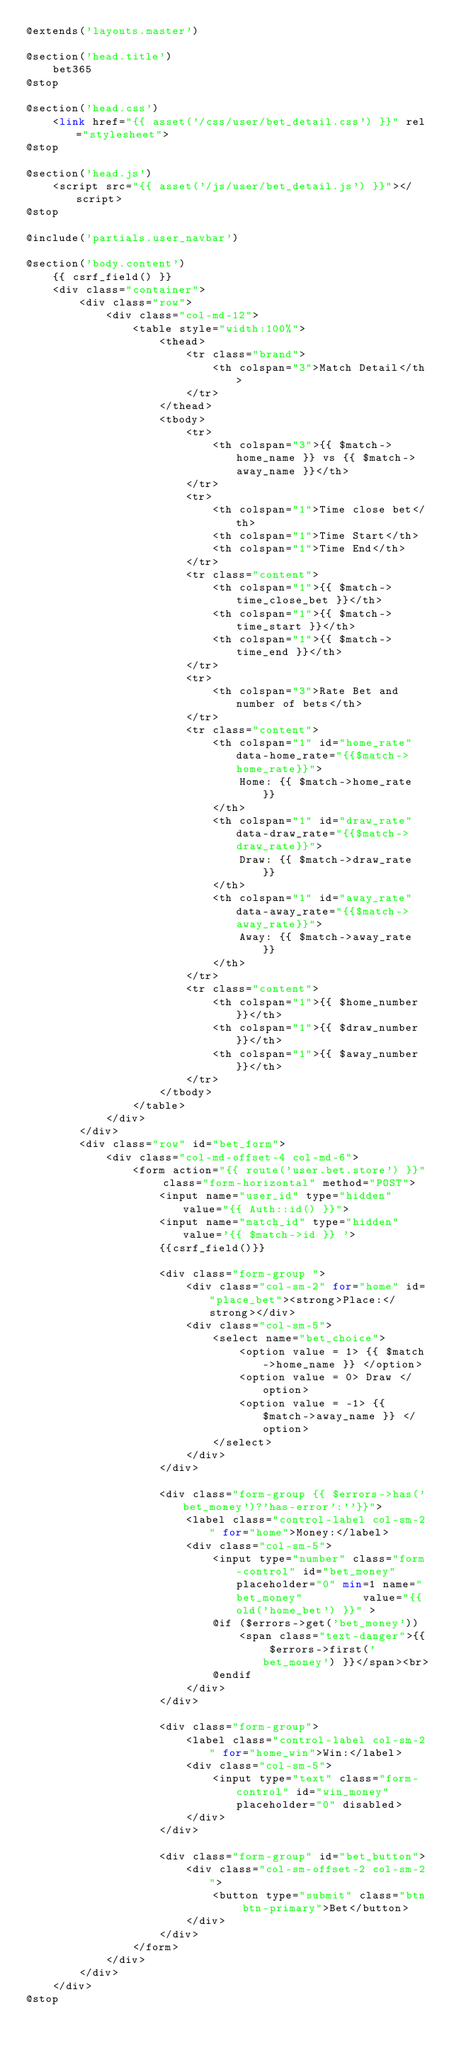<code> <loc_0><loc_0><loc_500><loc_500><_PHP_>@extends('layouts.master')

@section('head.title')
    bet365
@stop

@section('head.css')
    <link href="{{ asset('/css/user/bet_detail.css') }}" rel="stylesheet">
@stop

@section('head.js')
    <script src="{{ asset('/js/user/bet_detail.js') }}"></script> 
@stop

@include('partials.user_navbar')

@section('body.content')
    {{ csrf_field() }}
    <div class="container">
        <div class="row">
            <div class="col-md-12">
                <table style="width:100%">
                    <thead>
                        <tr class="brand">
                            <th colspan="3">Match Detail</th>
                        </tr>
                    </thead>
                    <tbody>
                        <tr>
                            <th colspan="3">{{ $match->home_name }} vs {{ $match->away_name }}</th>
                        </tr>
                        <tr>
                            <th colspan="1">Time close bet</th>
                            <th colspan="1">Time Start</th>
                            <th colspan="1">Time End</th>
                        </tr>
                        <tr class="content">
                            <th colspan="1">{{ $match->time_close_bet }}</th>
                            <th colspan="1">{{ $match->time_start }}</th>
                            <th colspan="1">{{ $match->time_end }}</th>
                        </tr>
                        <tr>
                            <th colspan="3">Rate Bet and number of bets</th>
                        </tr>
                        <tr class="content">
                            <th colspan="1" id="home_rate" data-home_rate="{{$match->home_rate}}">
                                Home: {{ $match->home_rate }}
                            </th>
                            <th colspan="1" id="draw_rate" data-draw_rate="{{$match->draw_rate}}">
                                Draw: {{ $match->draw_rate }}
                            </th>
                            <th colspan="1" id="away_rate" data-away_rate="{{$match->away_rate}}">
                                Away: {{ $match->away_rate }}
                            </th>
                        </tr>
                        <tr class="content">
                            <th colspan="1">{{ $home_number }}</th>
                            <th colspan="1">{{ $draw_number }}</th>
                            <th colspan="1">{{ $away_number }}</th>
                        </tr>
                    </tbody>
                </table>
            </div>
        </div>
        <div class="row" id="bet_form">
            <div class="col-md-offset-4 col-md-6">
                <form action="{{ route('user.bet.store') }}" class="form-horizontal" method="POST">
                    <input name="user_id" type="hidden" value="{{ Auth::id() }}">
                    <input name="match_id" type="hidden" value='{{ $match->id }} '>
                    {{csrf_field()}}

                    <div class="form-group ">
                        <div class="col-sm-2" for="home" id="place_bet"><strong>Place:</strong></div>
                        <div class="col-sm-5">
                            <select name="bet_choice">
                                <option value = 1> {{ $match->home_name }} </option>
                                <option value = 0> Draw </option>
                                <option value = -1> {{ $match->away_name }} </option>
                            </select>
                        </div>
                    </div>
    
                    <div class="form-group {{ $errors->has('bet_money')?'has-error':''}}">
                        <label class="control-label col-sm-2" for="home">Money:</label>
                        <div class="col-sm-5">
                            <input type="number" class="form-control" id="bet_money" placeholder="0" min=1 name="bet_money"         value="{{ old('home_bet') }}" >
                            @if ($errors->get('bet_money'))
                                <span class="text-danger">{{ $errors->first('bet_money') }}</span><br>
                            @endif
                        </div>
                    </div>

                    <div class="form-group">
                        <label class="control-label col-sm-2" for="home_win">Win:</label>
                        <div class="col-sm-5">
                            <input type="text" class="form-control" id="win_money" placeholder="0" disabled>
                        </div>
                    </div>
                  
                    <div class="form-group" id="bet_button"> 
                        <div class="col-sm-offset-2 col-sm-2">
                            <button type="submit" class="btn btn-primary">Bet</button>
                        </div>
                    </div>
                </form>
            </div>
        </div>
    </div>
@stop</code> 